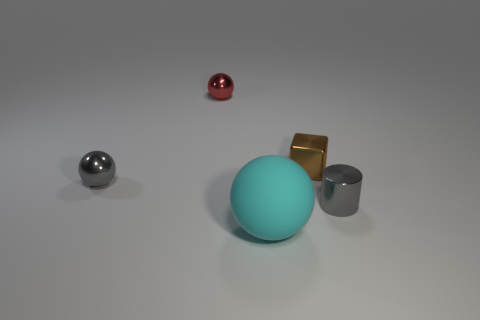What textures do the objects in the image have? The cyan sphere has a matte texture which absorbs light. The metallic spheres and cubes have a smooth and shiny texture that reflects light, giving them a glossy appearance. 